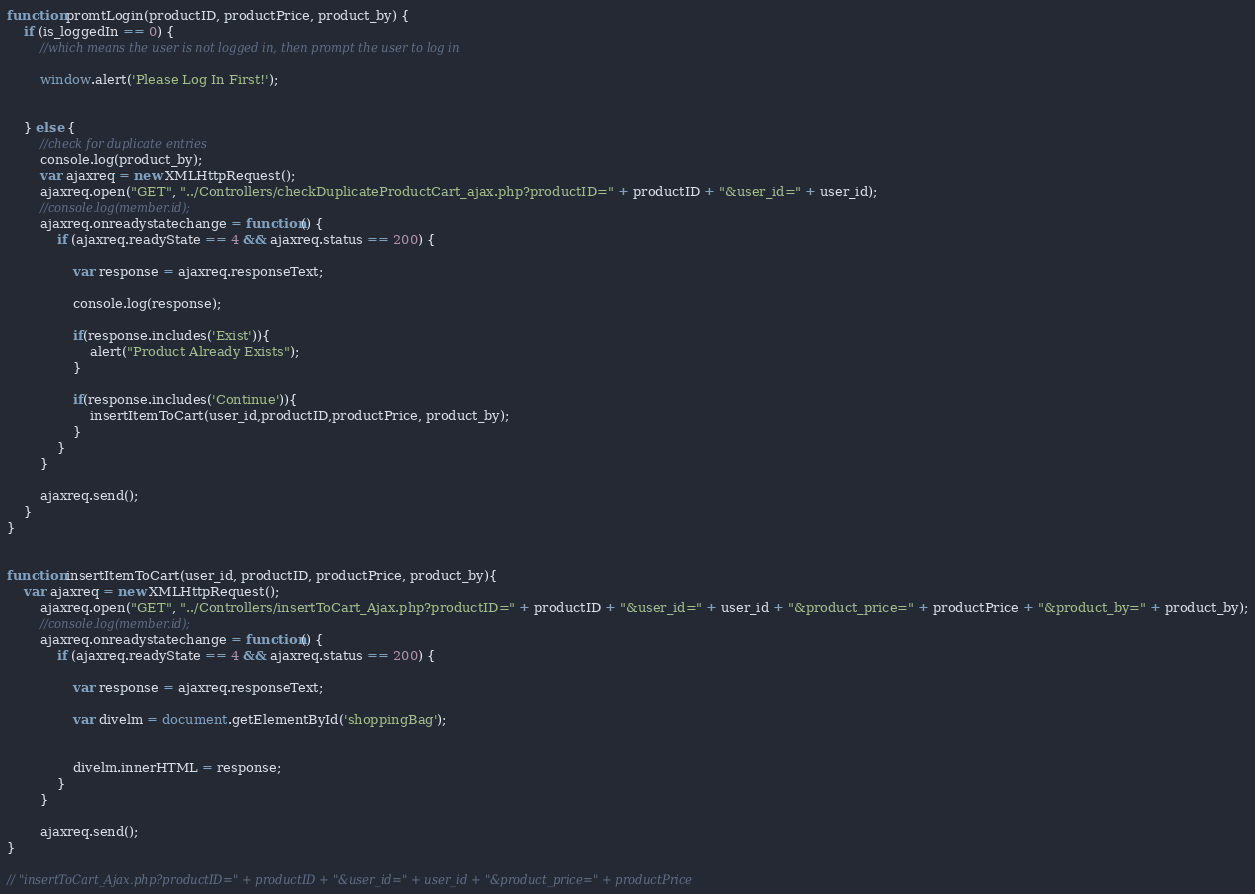Convert code to text. <code><loc_0><loc_0><loc_500><loc_500><_JavaScript_>function promtLogin(productID, productPrice, product_by) {
    if (is_loggedIn == 0) {
        //which means the user is not logged in, then prompt the user to log in

        window.alert('Please Log In First!');


    } else {
        //check for duplicate entries
        console.log(product_by);
        var ajaxreq = new XMLHttpRequest();
        ajaxreq.open("GET", "../Controllers/checkDuplicateProductCart_ajax.php?productID=" + productID + "&user_id=" + user_id);
        //console.log(member.id);
        ajaxreq.onreadystatechange = function() {
            if (ajaxreq.readyState == 4 && ajaxreq.status == 200) {

                var response = ajaxreq.responseText;

                console.log(response);

                if(response.includes('Exist')){
                    alert("Product Already Exists");
                }
                
                if(response.includes('Continue')){
                    insertItemToCart(user_id,productID,productPrice, product_by);
                }
            }
        }

        ajaxreq.send();
    }
}


function insertItemToCart(user_id, productID, productPrice, product_by){
    var ajaxreq = new XMLHttpRequest();
        ajaxreq.open("GET", "../Controllers/insertToCart_Ajax.php?productID=" + productID + "&user_id=" + user_id + "&product_price=" + productPrice + "&product_by=" + product_by);
        //console.log(member.id);
        ajaxreq.onreadystatechange = function() {
            if (ajaxreq.readyState == 4 && ajaxreq.status == 200) {

                var response = ajaxreq.responseText;

                var divelm = document.getElementById('shoppingBag');


                divelm.innerHTML = response;
            }
        }

        ajaxreq.send();
}

// "insertToCart_Ajax.php?productID=" + productID + "&user_id=" + user_id + "&product_price=" + productPrice</code> 